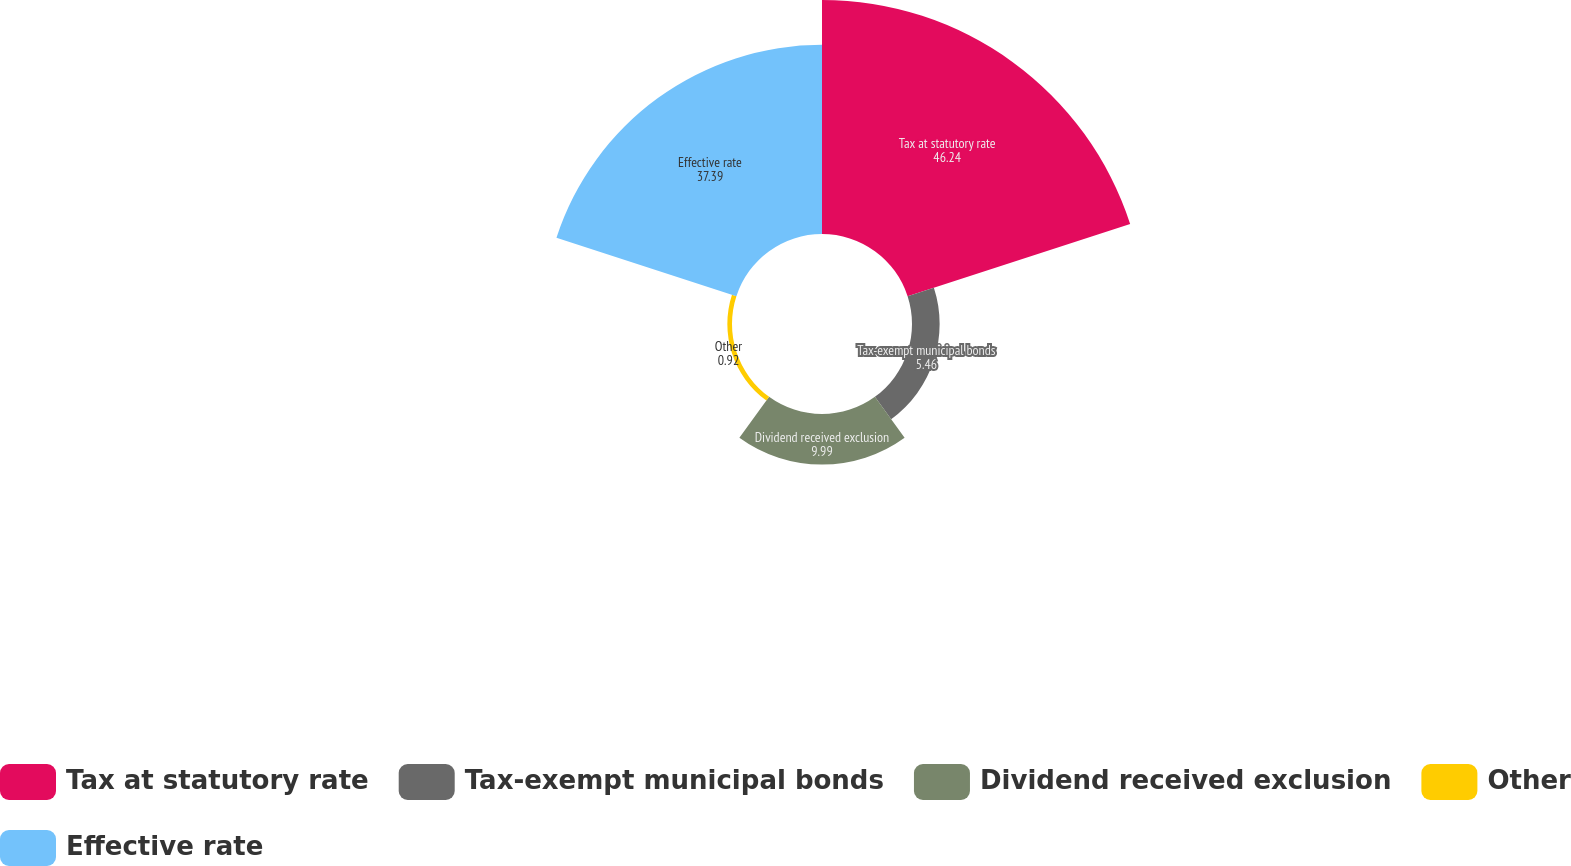Convert chart. <chart><loc_0><loc_0><loc_500><loc_500><pie_chart><fcel>Tax at statutory rate<fcel>Tax-exempt municipal bonds<fcel>Dividend received exclusion<fcel>Other<fcel>Effective rate<nl><fcel>46.24%<fcel>5.46%<fcel>9.99%<fcel>0.92%<fcel>37.39%<nl></chart> 